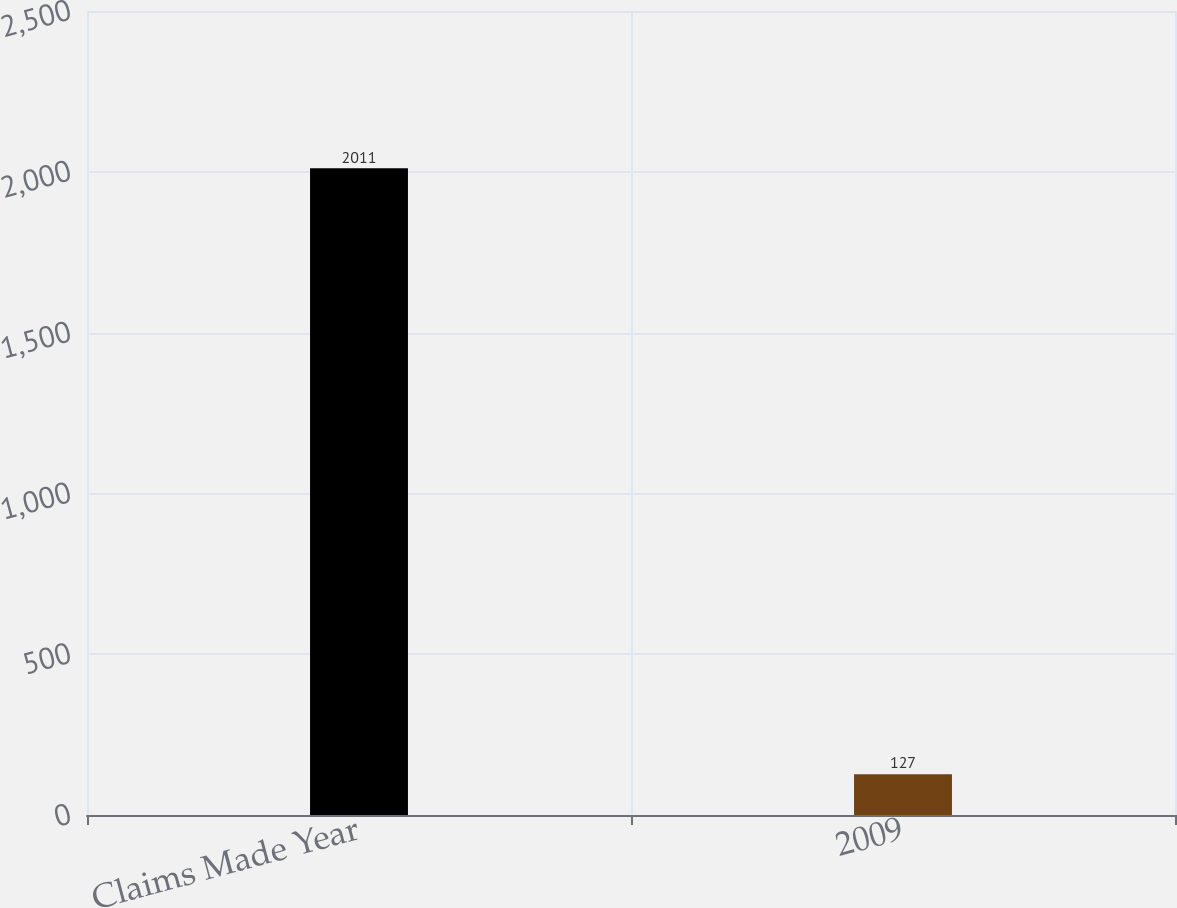<chart> <loc_0><loc_0><loc_500><loc_500><bar_chart><fcel>Claims Made Year<fcel>2009<nl><fcel>2011<fcel>127<nl></chart> 